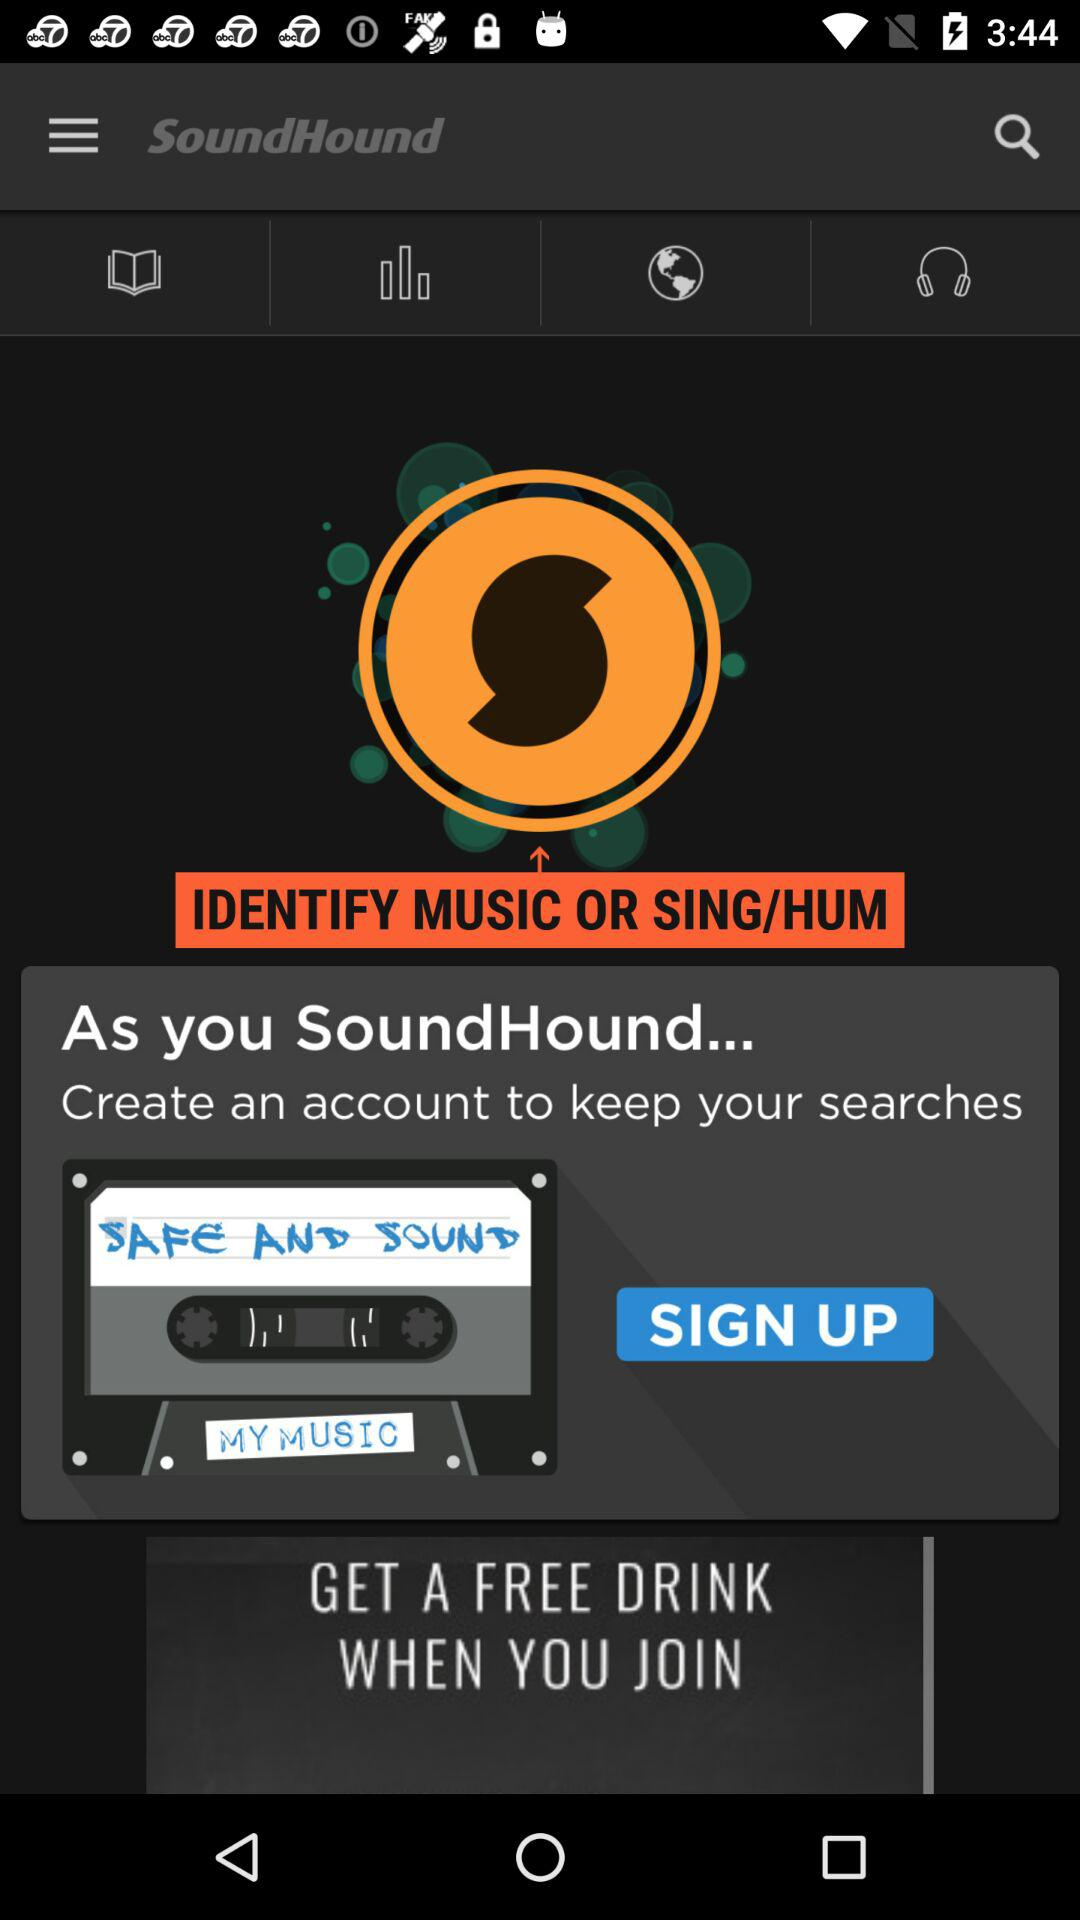What is the name of the application? The application name is "SoundHound". 